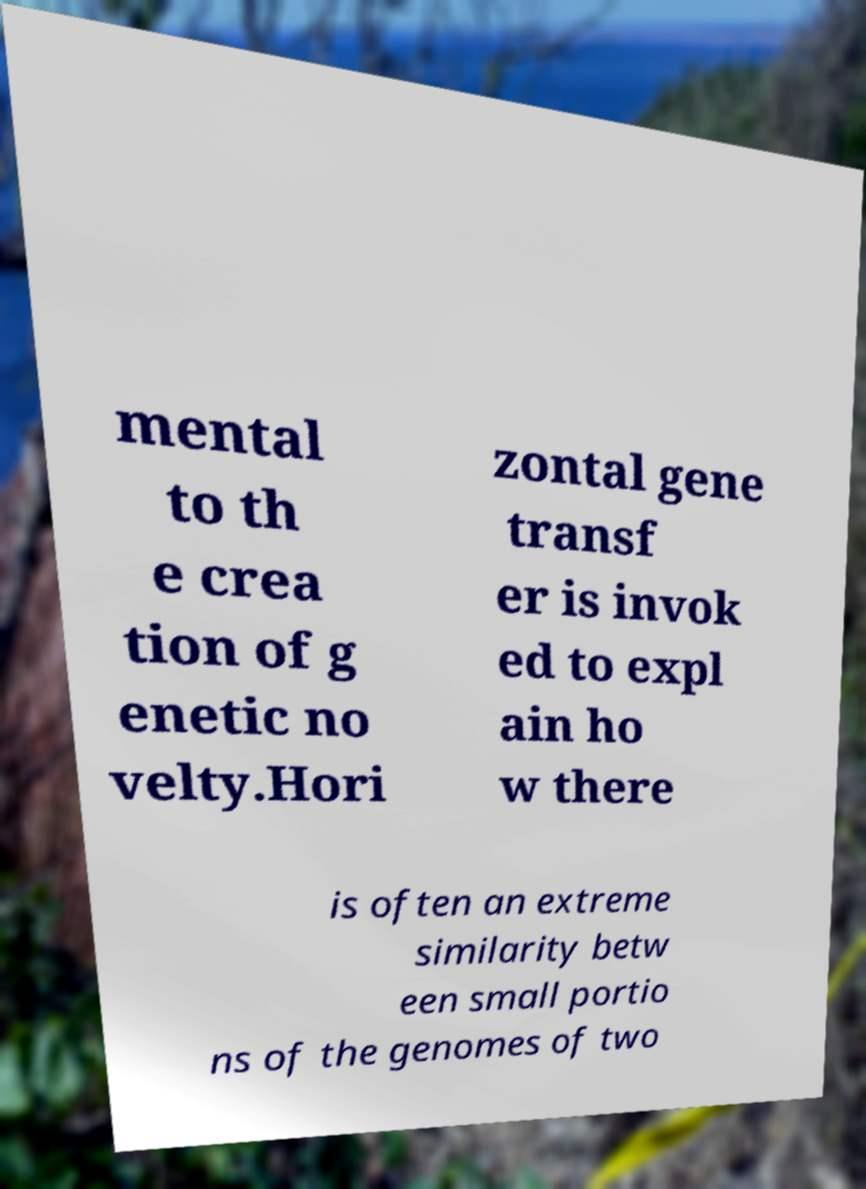I need the written content from this picture converted into text. Can you do that? mental to th e crea tion of g enetic no velty.Hori zontal gene transf er is invok ed to expl ain ho w there is often an extreme similarity betw een small portio ns of the genomes of two 